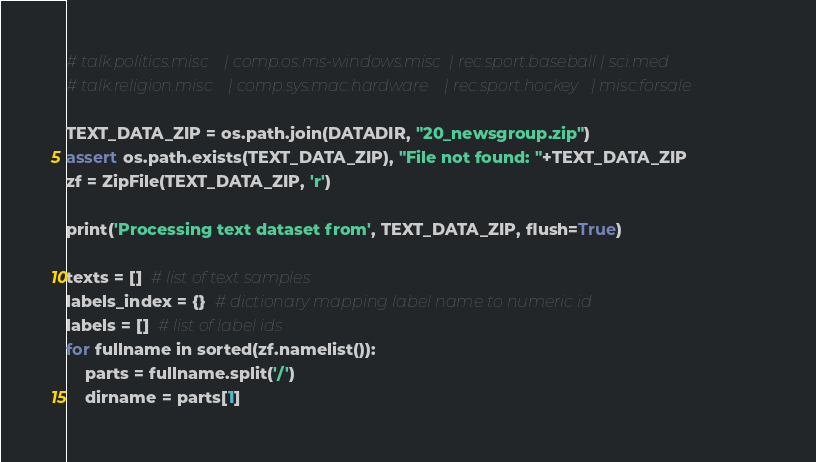<code> <loc_0><loc_0><loc_500><loc_500><_Python_># talk.politics.misc    | comp.os.ms-windows.misc  | rec.sport.baseball | sci.med
# talk.religion.misc    | comp.sys.mac.hardware    | rec.sport.hockey   | misc.forsale

TEXT_DATA_ZIP = os.path.join(DATADIR, "20_newsgroup.zip")
assert os.path.exists(TEXT_DATA_ZIP), "File not found: "+TEXT_DATA_ZIP
zf = ZipFile(TEXT_DATA_ZIP, 'r')

print('Processing text dataset from', TEXT_DATA_ZIP, flush=True)

texts = []  # list of text samples
labels_index = {}  # dictionary mapping label name to numeric id
labels = []  # list of label ids
for fullname in sorted(zf.namelist()):
    parts = fullname.split('/')
    dirname = parts[1]</code> 